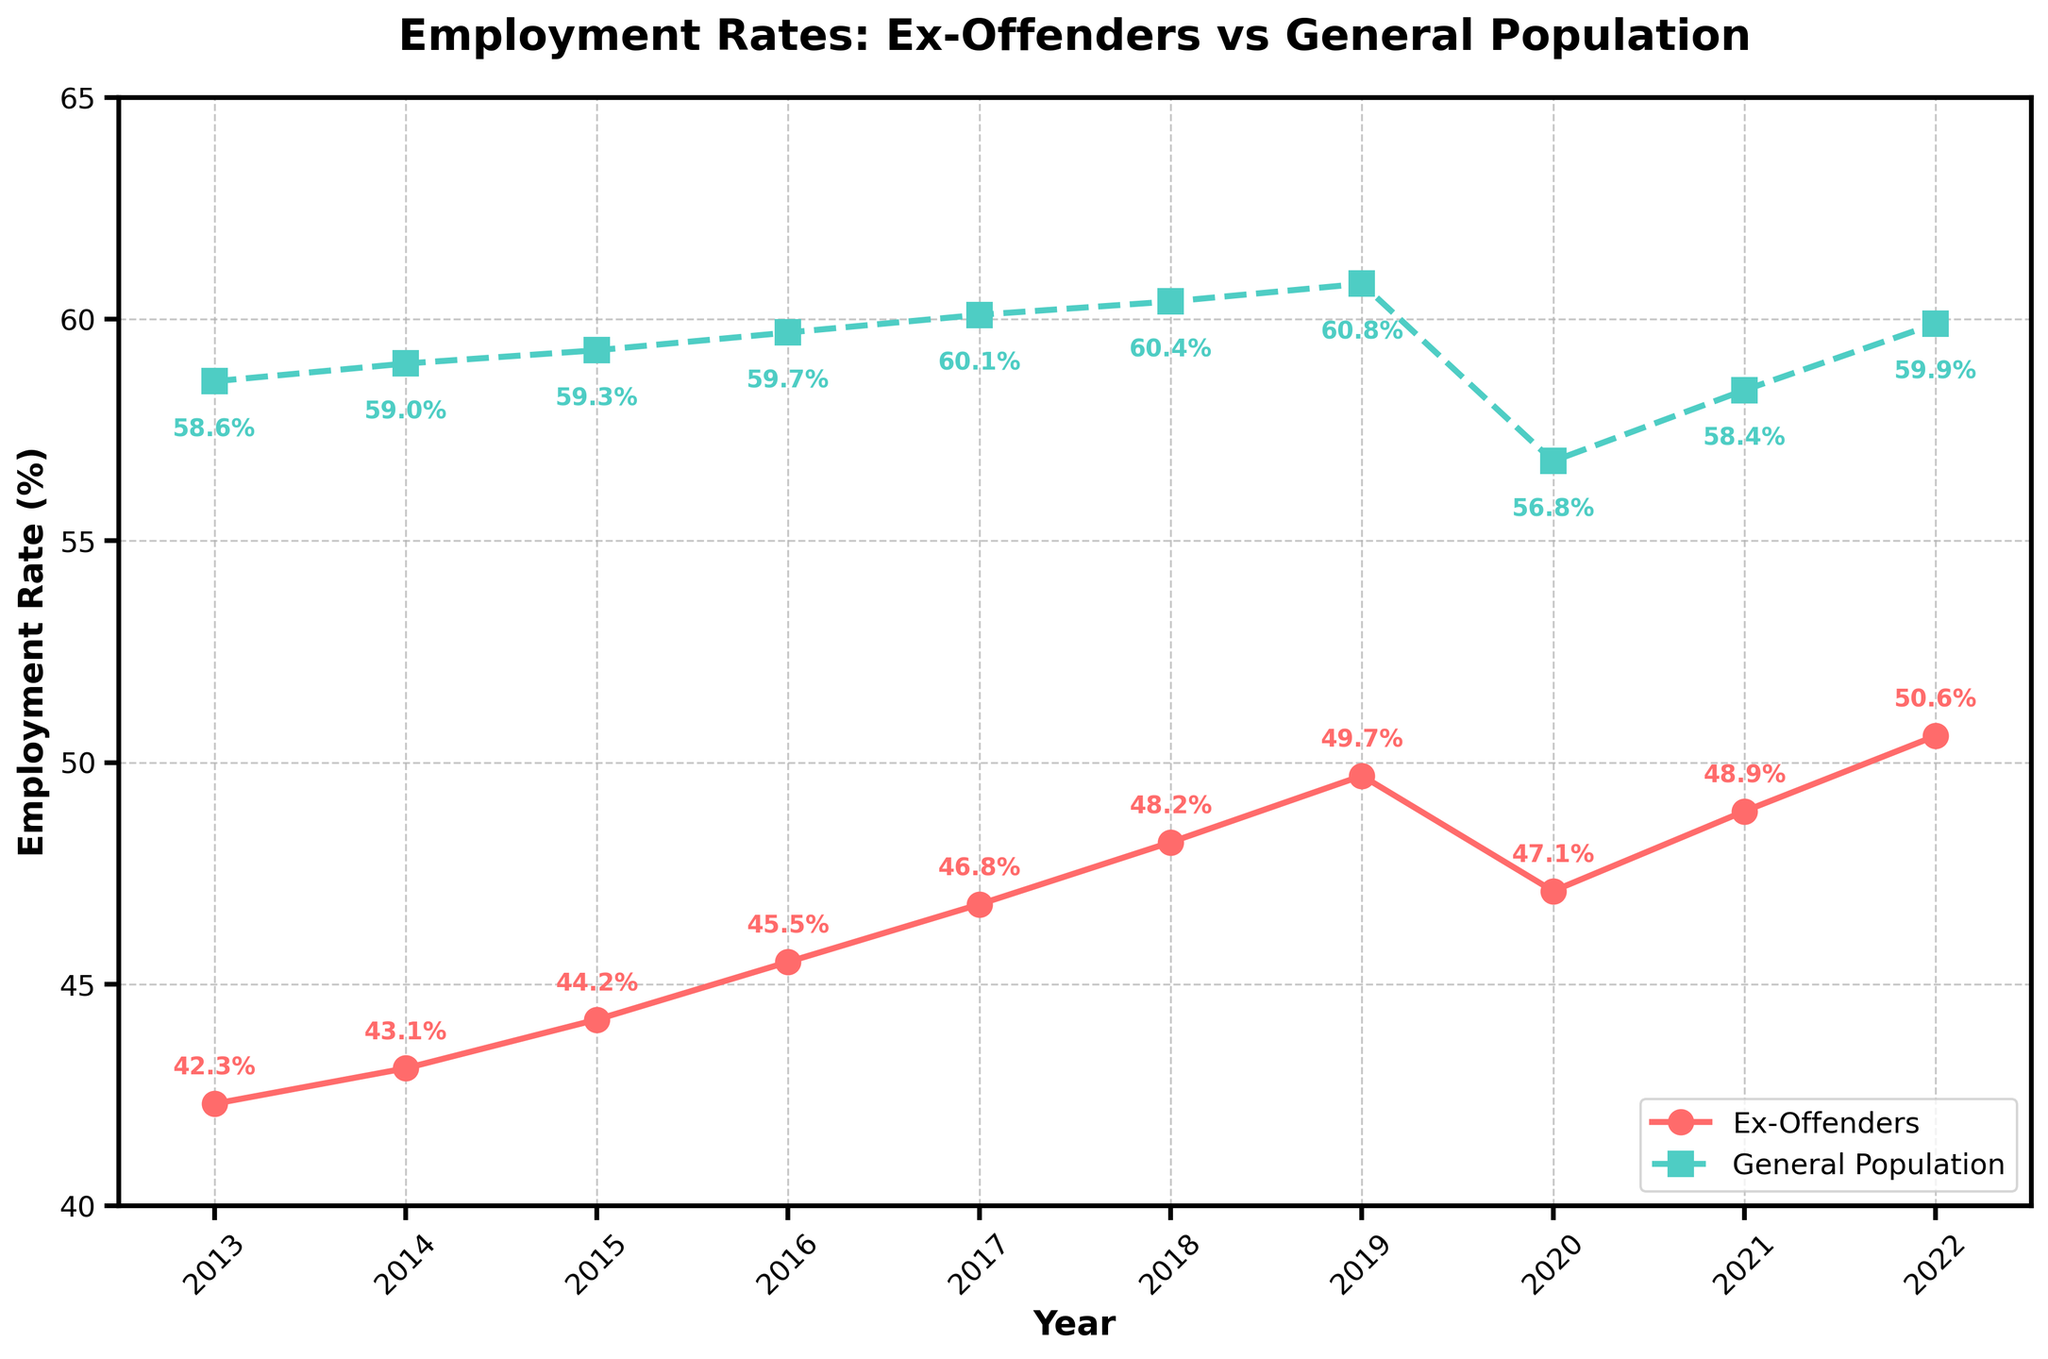What was the employment rate of ex-offenders and the general population in 2015? The data for the year 2015 shows an employment rate of 44.2% for ex-offenders and 59.3% for the general population.
Answer: 44.2%, 59.3% In which year did ex-offenders see the highest employment rate? By looking at the trend line for ex-offenders, the highest employment rate is seen in 2022.
Answer: 2022 How did the employment rate of ex-offenders change from 2019 to 2020? The employment rate for ex-offenders dropped from 49.7% in 2019 to 47.1% in 2020.
Answer: Decreased Which group had a larger drop in employment rate during 2020, and by how much? Compare the employment rates from 2019 to 2020: For ex-offenders, the drop is 49.7% - 47.1% = 2.6%. For the general population, it is 60.8% - 56.8% = 4%. Thus, the general population had a larger drop of 4% - 2.6% = 1.4%.
Answer: General population, 1.4% On average, what was the employment rate of ex-offenders from 2013 to 2022? Calculate the average of ex-offenders employment rates over the 10 years: (42.3 + 43.1 + 44.2 + 45.5 + 46.8 + 48.2 + 49.7 + 47.1 + 48.9 + 50.6) / 10 = 46.64%.
Answer: 46.64% During which years did ex-offenders have an employment rate above 48%? Check the years where the ex-offenders rate is above 48%: These years are 2018, 2019, 2021, and 2022.
Answer: 2018, 2019, 2021, 2022 What is the trend in employment rates for ex-offenders vs. general population over the 10-year period? Observing the plot over the 10-year period, ex-offenders show a generally increasing trend in employment rates, while the general population's rate remains relatively stable with a slight dip in 2020.
Answer: Increasing for ex-offenders, Stable for general population Which year has the smallest gap in employment rates between ex-offenders and the general population? Calculate the gap for each year and find the smallest difference: The smallest gap is in 2022, with a difference of 59.9% - 50.6% = 9.3%.
Answer: 2022, 9.3% How many years did the general population's employment rate exceed 60%? Check the years where the general population's rate exceeded 60%: These years are 2017, 2018, and 2019.
Answer: 3 years What can be inferred about the resilience of ex-offenders' employment rates compared to the general population during the COVID-19 pandemic in 2020? The drop in employment rate from 2019 to 2020 is less steep for ex-offenders (2.6%) compared to the general population (4%). This indicates that ex-offenders showed somewhat more resilience during the pandemic.
Answer: More resilient 